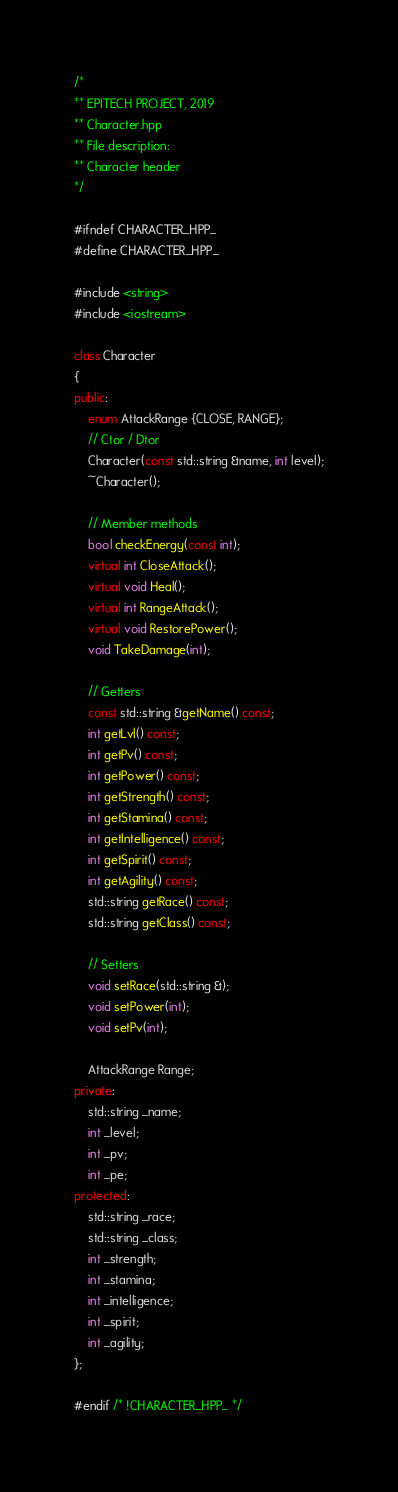Convert code to text. <code><loc_0><loc_0><loc_500><loc_500><_C++_>/*
** EPITECH PROJECT, 2019
** Character.hpp
** File description:
** Character header
*/

#ifndef CHARACTER_HPP_
#define CHARACTER_HPP_

#include <string>
#include <iostream>

class Character
{
public:
    enum AttackRange {CLOSE, RANGE};
    // Ctor / Dtor
    Character(const std::string &name, int level);
    ~Character();

    // Member methods
    bool checkEnergy(const int);
    virtual int CloseAttack();
    virtual void Heal();
    virtual int RangeAttack();
    virtual void RestorePower();
    void TakeDamage(int);

    // Getters
    const std::string &getName() const;
    int getLvl() const;
    int getPv() const;
    int getPower() const;
    int getStrength() const;
    int getStamina() const;
    int getIntelligence() const;
    int getSpirit() const;
    int getAgility() const;
    std::string getRace() const;
    std::string getClass() const;

    // Setters
    void setRace(std::string &);
    void setPower(int);
    void setPv(int);

    AttackRange Range;
private:
    std::string _name;
    int _level;
    int _pv;
    int _pe;
protected:
    std::string _race;
    std::string _class;
    int _strength;
    int _stamina;
    int _intelligence;
    int _spirit;
    int _agility;
};

#endif /* !CHARACTER_HPP_ */
</code> 